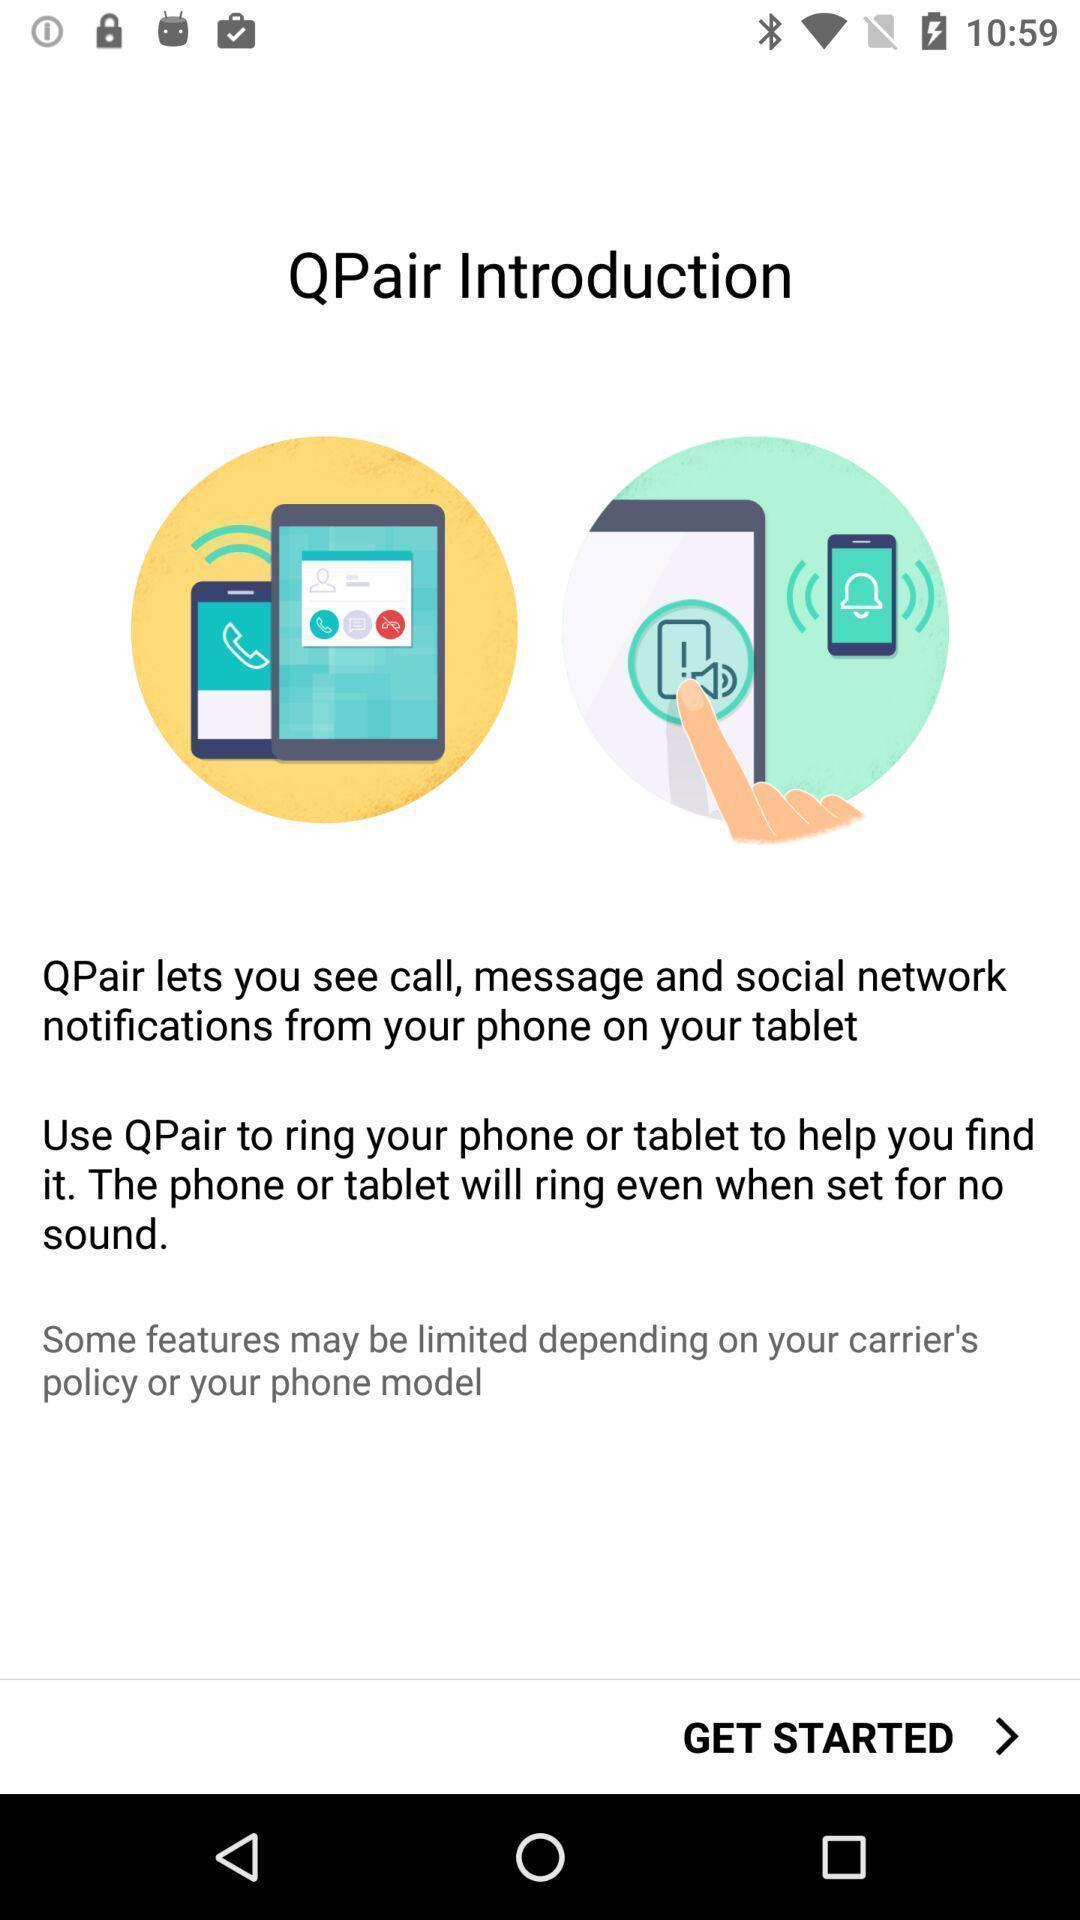Summarize the main components in this picture. Page displaying the introduction. 